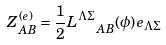<formula> <loc_0><loc_0><loc_500><loc_500>Z _ { A B } ^ { ( e ) } = { \frac { 1 } { 2 } } L _ { \ \ A B } ^ { \Lambda \Sigma } ( \phi ) e _ { \Lambda \Sigma }</formula> 